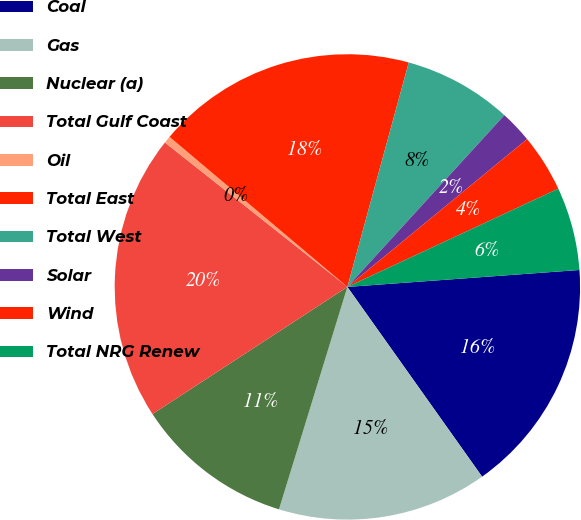<chart> <loc_0><loc_0><loc_500><loc_500><pie_chart><fcel>Coal<fcel>Gas<fcel>Nuclear (a)<fcel>Total Gulf Coast<fcel>Oil<fcel>Total East<fcel>Total West<fcel>Solar<fcel>Wind<fcel>Total NRG Renew<nl><fcel>16.34%<fcel>14.58%<fcel>11.06%<fcel>19.86%<fcel>0.5%<fcel>18.1%<fcel>7.54%<fcel>2.26%<fcel>4.02%<fcel>5.78%<nl></chart> 